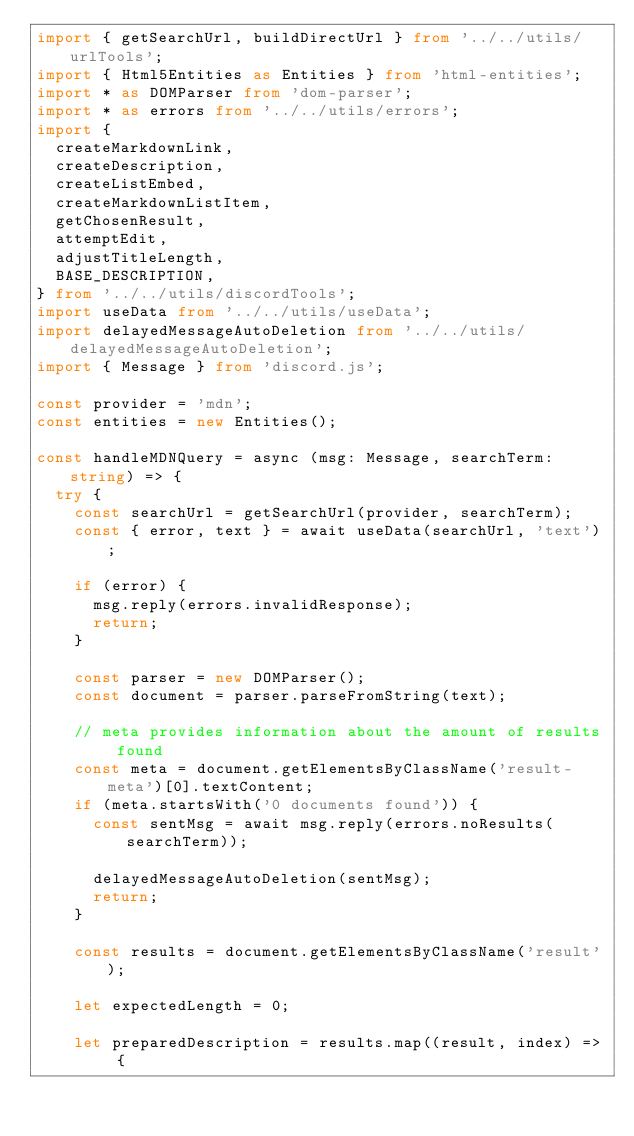Convert code to text. <code><loc_0><loc_0><loc_500><loc_500><_TypeScript_>import { getSearchUrl, buildDirectUrl } from '../../utils/urlTools';
import { Html5Entities as Entities } from 'html-entities';
import * as DOMParser from 'dom-parser';
import * as errors from '../../utils/errors';
import {
  createMarkdownLink,
  createDescription,
  createListEmbed,
  createMarkdownListItem,
  getChosenResult,
  attemptEdit,
  adjustTitleLength,
  BASE_DESCRIPTION,
} from '../../utils/discordTools';
import useData from '../../utils/useData';
import delayedMessageAutoDeletion from '../../utils/delayedMessageAutoDeletion';
import { Message } from 'discord.js';

const provider = 'mdn';
const entities = new Entities();

const handleMDNQuery = async (msg: Message, searchTerm: string) => {
  try {
    const searchUrl = getSearchUrl(provider, searchTerm);
    const { error, text } = await useData(searchUrl, 'text');

    if (error) {
      msg.reply(errors.invalidResponse);
      return;
    }

    const parser = new DOMParser();
    const document = parser.parseFromString(text);

    // meta provides information about the amount of results found
    const meta = document.getElementsByClassName('result-meta')[0].textContent;
    if (meta.startsWith('0 documents found')) {
      const sentMsg = await msg.reply(errors.noResults(searchTerm));

      delayedMessageAutoDeletion(sentMsg);
      return;
    }

    const results = document.getElementsByClassName('result');

    let expectedLength = 0;

    let preparedDescription = results.map((result, index) => {</code> 